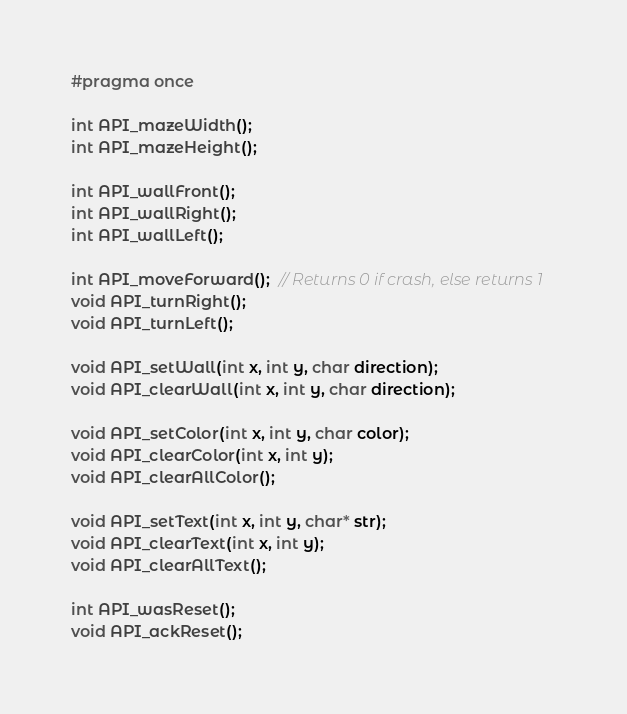<code> <loc_0><loc_0><loc_500><loc_500><_C_>#pragma once

int API_mazeWidth();
int API_mazeHeight();

int API_wallFront();
int API_wallRight();
int API_wallLeft();

int API_moveForward();  // Returns 0 if crash, else returns 1
void API_turnRight();
void API_turnLeft();

void API_setWall(int x, int y, char direction);
void API_clearWall(int x, int y, char direction);

void API_setColor(int x, int y, char color);
void API_clearColor(int x, int y);
void API_clearAllColor();

void API_setText(int x, int y, char* str);
void API_clearText(int x, int y);
void API_clearAllText();

int API_wasReset();
void API_ackReset();
</code> 